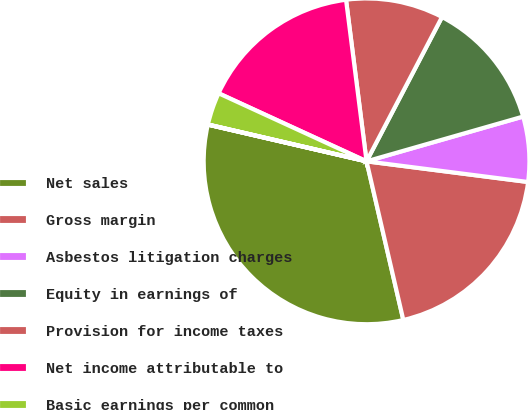Convert chart to OTSL. <chart><loc_0><loc_0><loc_500><loc_500><pie_chart><fcel>Net sales<fcel>Gross margin<fcel>Asbestos litigation charges<fcel>Equity in earnings of<fcel>Provision for income taxes<fcel>Net income attributable to<fcel>Basic earnings per common<fcel>Diluted earnings per common<nl><fcel>32.25%<fcel>19.35%<fcel>6.46%<fcel>12.9%<fcel>9.68%<fcel>16.13%<fcel>3.23%<fcel>0.01%<nl></chart> 